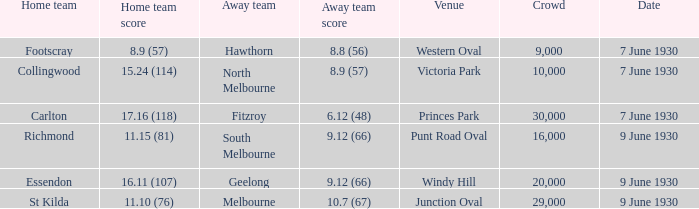What is the smallest crowd to see the away team score 10.7 (67)? 29000.0. 